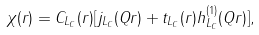Convert formula to latex. <formula><loc_0><loc_0><loc_500><loc_500>\chi ( r ) = C _ { L _ { C } } ( r ) [ j _ { L _ { C } } ( Q r ) + t _ { L _ { C } } ( r ) h ^ { ( 1 ) } _ { L _ { C } } ( Q r ) ] ,</formula> 